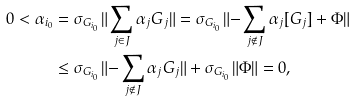<formula> <loc_0><loc_0><loc_500><loc_500>0 < \alpha _ { i _ { 0 } } & = \sigma _ { G _ { i _ { 0 } } } \| \sum _ { j \in J } \alpha _ { j } G _ { j } \| = \sigma _ { G _ { i _ { 0 } } } \| { - } \sum _ { j \notin J } \alpha _ { j } [ G _ { j } ] + \Phi \| \\ & \leq \sigma _ { G _ { i _ { 0 } } } \| { - } \sum _ { j \notin J } \alpha _ { j } G _ { j } \| + \sigma _ { G _ { i _ { 0 } } } \| \Phi \| = 0 ,</formula> 